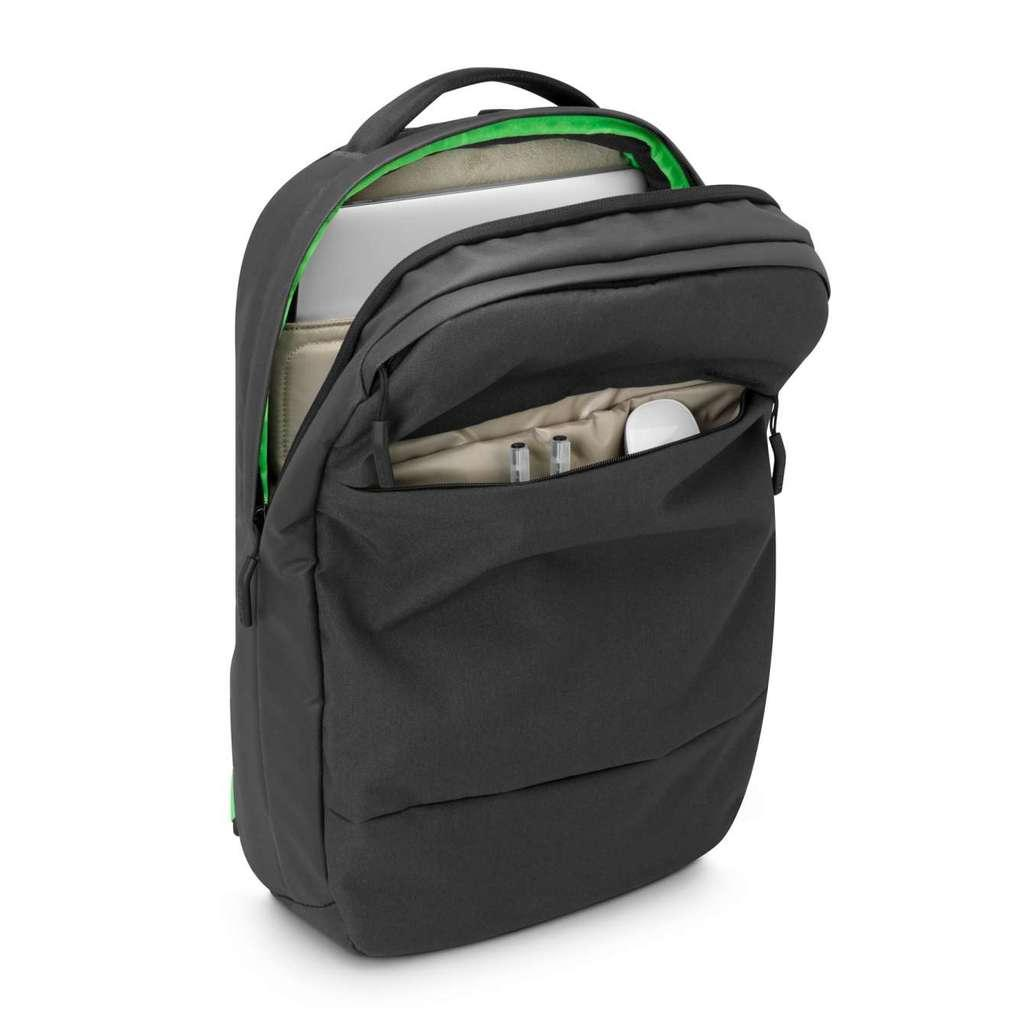What object is visible in the image? There is a bag in the image. What items are inside the bag? There is a laptop, two pens, and a mouse in the bag. What type of balls can be seen in the image? There are no balls visible in the image; it features a bag with a laptop, two pens, and a mouse inside. What does the bag smell like in the image? The provided facts do not mention any information about the smell of the bag, so it cannot be determined from the image. 